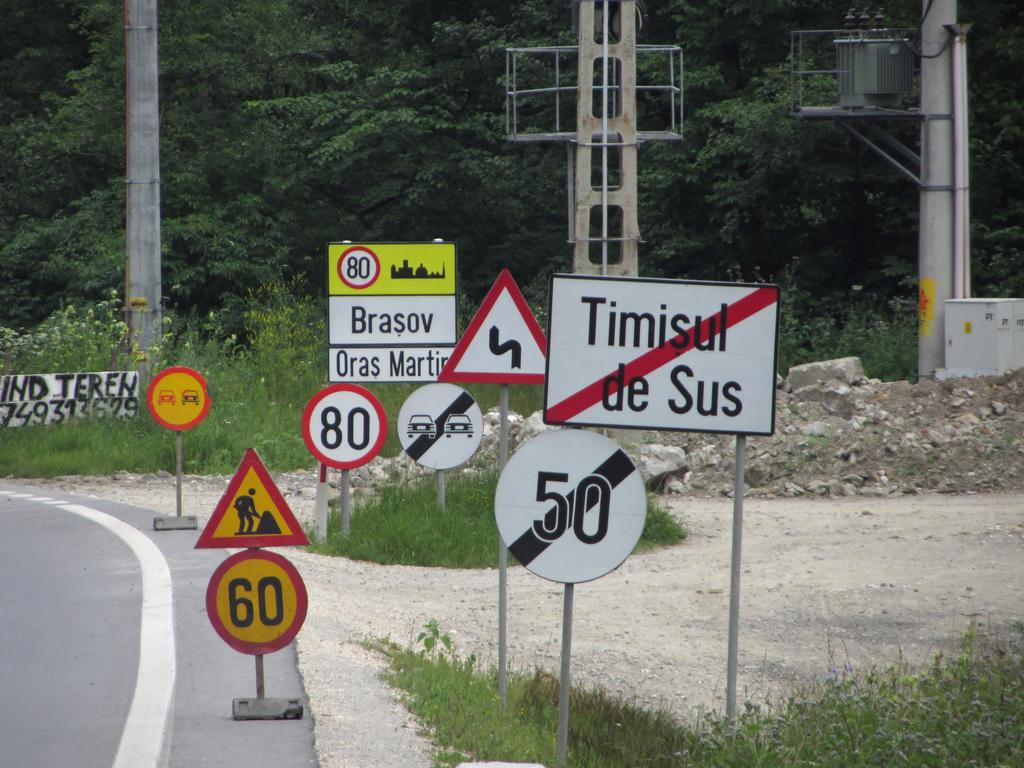Provide a one-sentence caption for the provided image. A cluster of street signs with speed limits of 60 are posted at a road. 